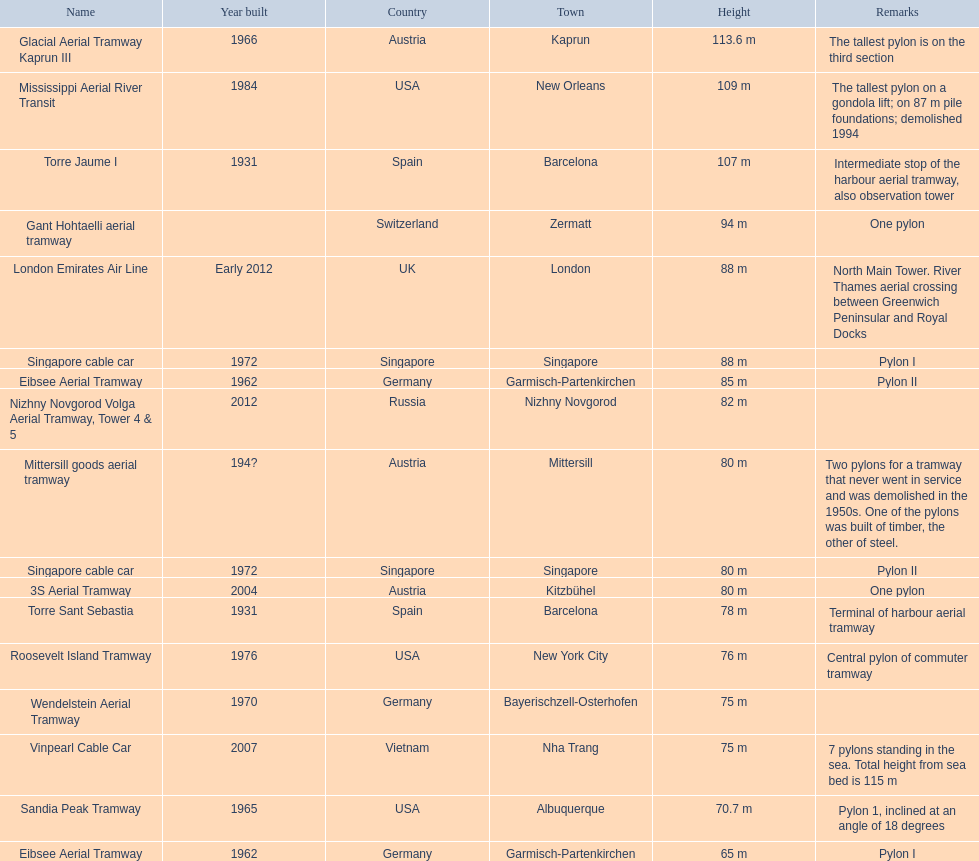Which sky lifts exceed 100 meters in height? Glacial Aerial Tramway Kaprun III, Mississippi Aerial River Transit, Torre Jaume I. Which one was constructed most recently? Mississippi Aerial River Transit. And what is its overall height? 109 m. 